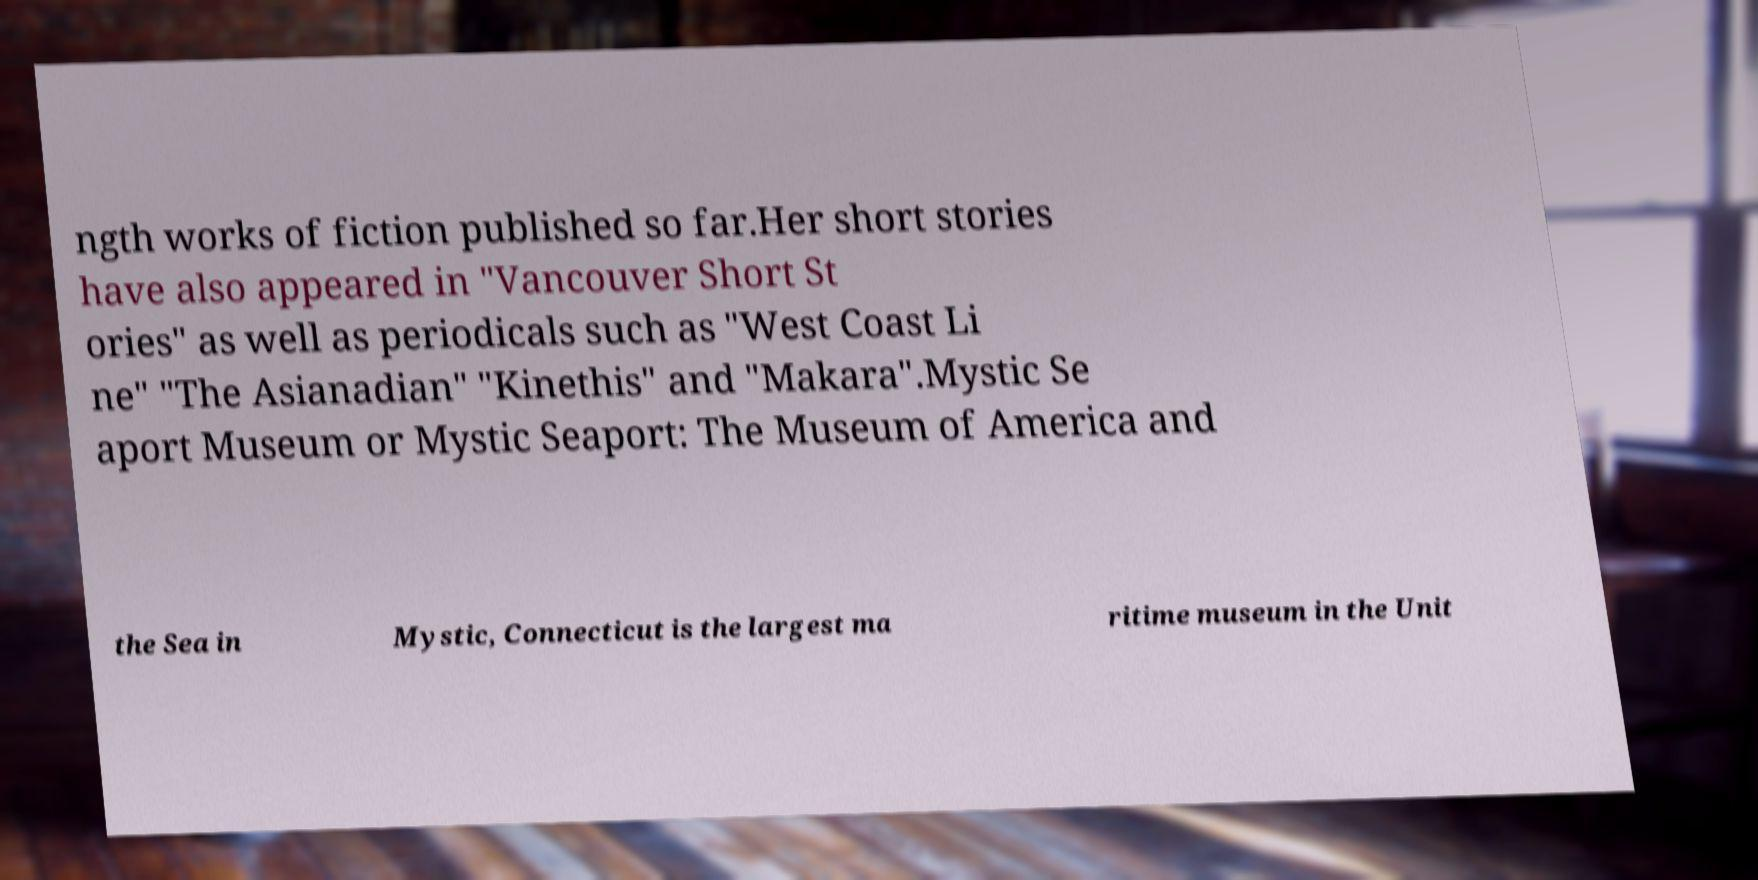For documentation purposes, I need the text within this image transcribed. Could you provide that? ngth works of fiction published so far.Her short stories have also appeared in "Vancouver Short St ories" as well as periodicals such as "West Coast Li ne" "The Asianadian" "Kinethis" and "Makara".Mystic Se aport Museum or Mystic Seaport: The Museum of America and the Sea in Mystic, Connecticut is the largest ma ritime museum in the Unit 